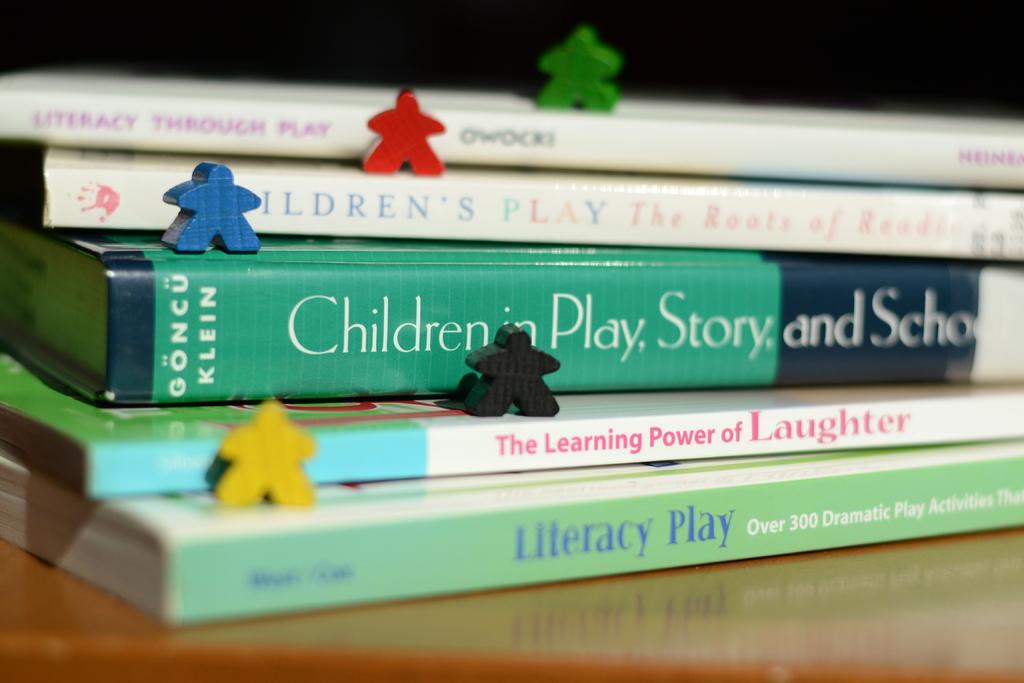What kind of play is being discussed in the book on the bottom?
Your response must be concise. Literacy. Whats a title of a book?
Provide a succinct answer. Literacy play. 